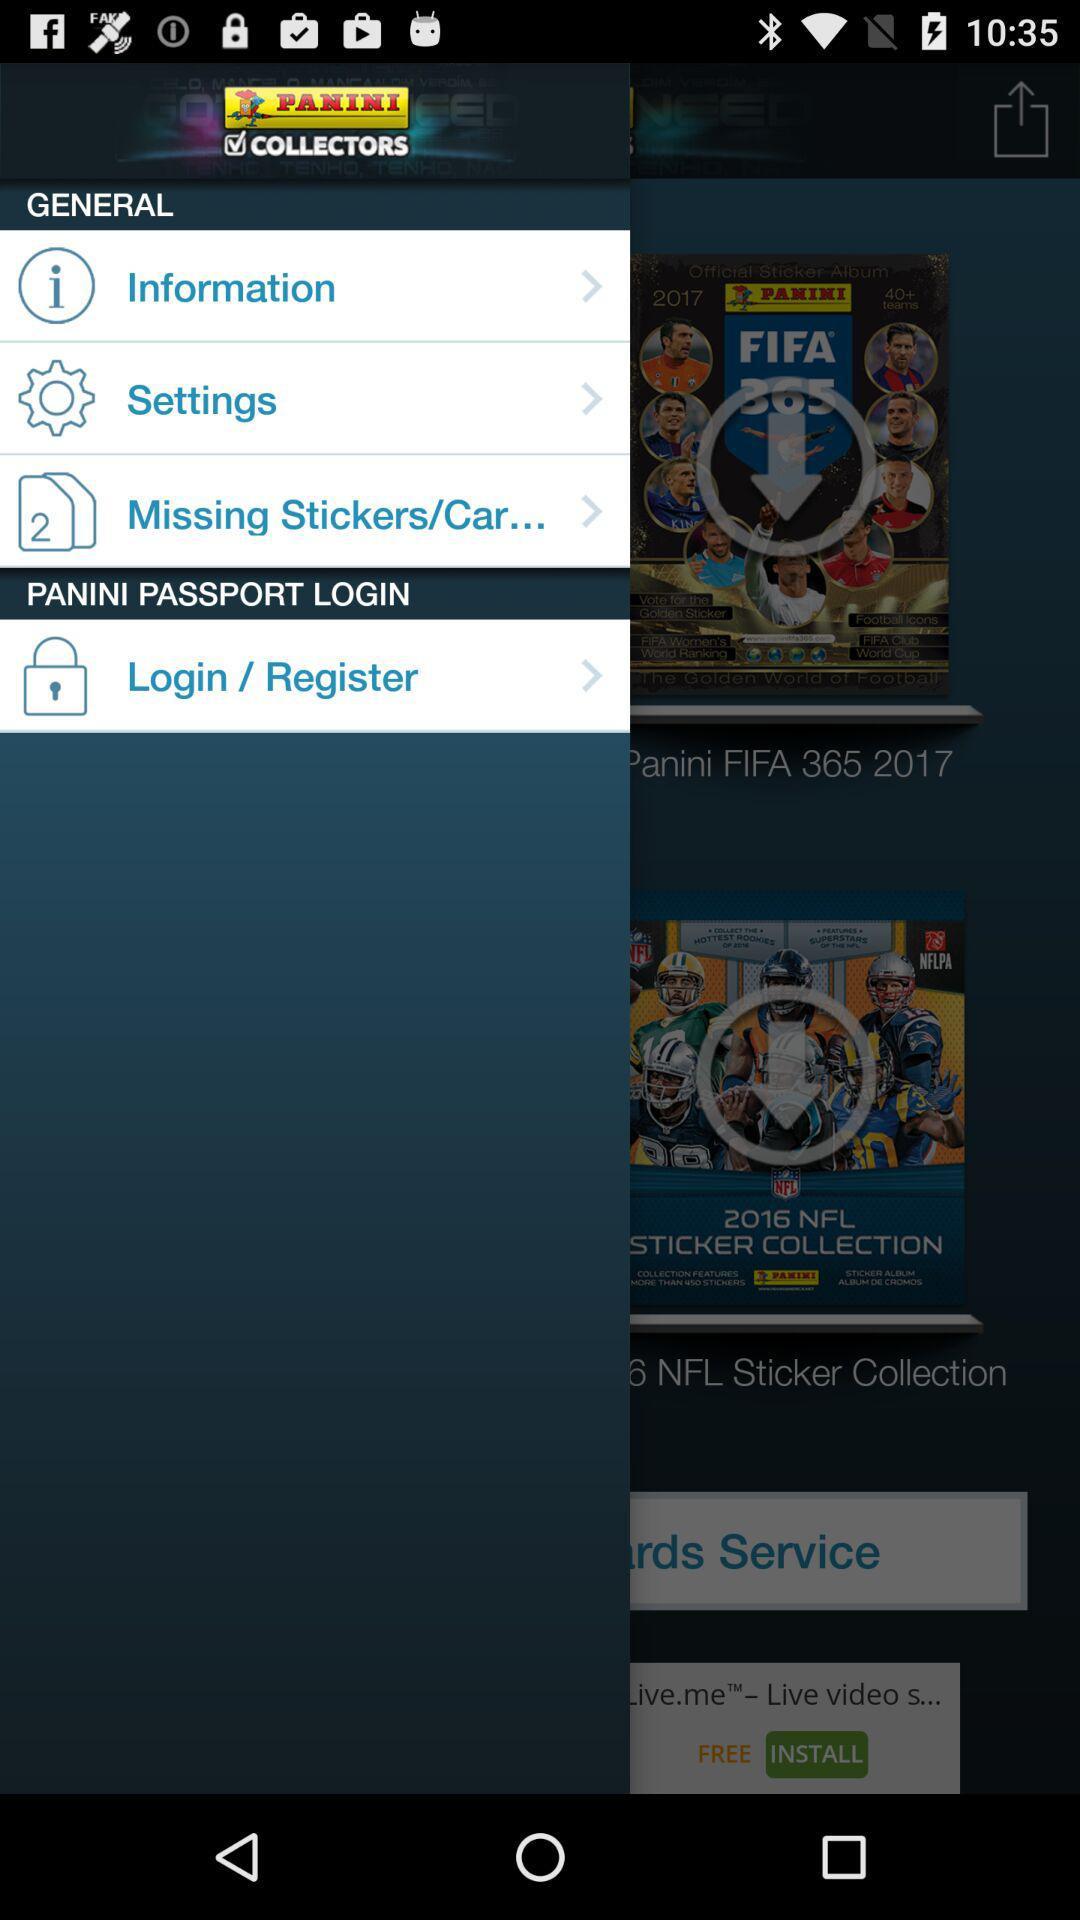What is the application name? The application name is "PANINI COLLECTORS". 